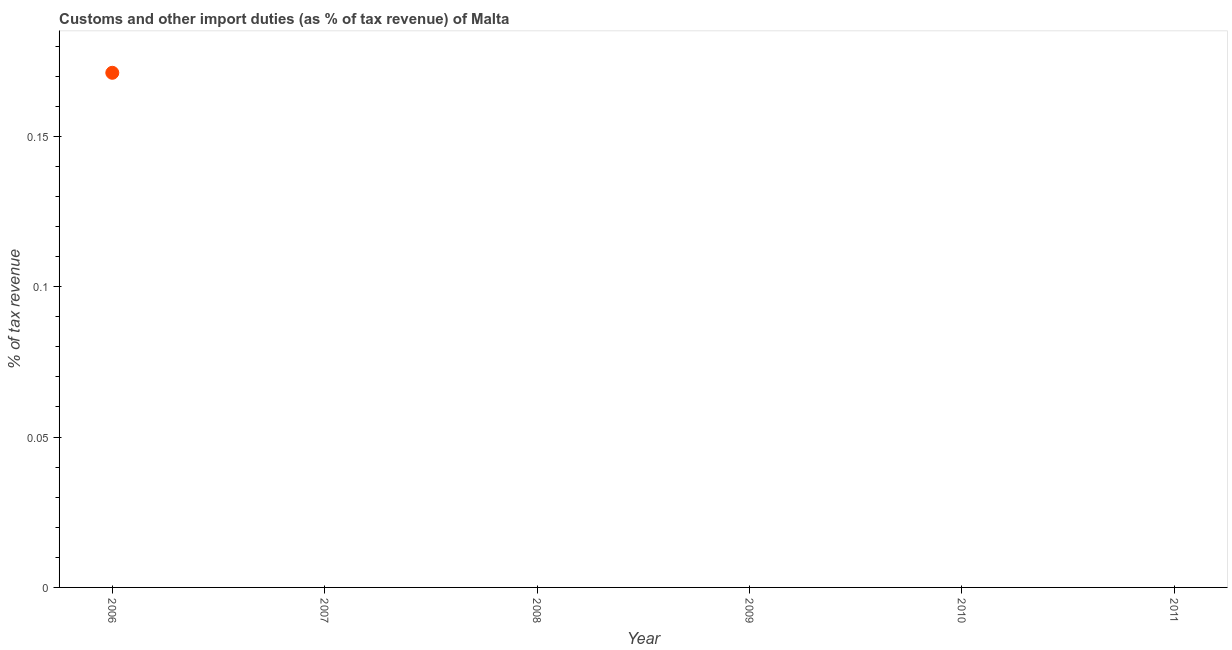What is the customs and other import duties in 2006?
Ensure brevity in your answer.  0.17. Across all years, what is the maximum customs and other import duties?
Make the answer very short. 0.17. In which year was the customs and other import duties maximum?
Ensure brevity in your answer.  2006. What is the sum of the customs and other import duties?
Make the answer very short. 0.17. What is the average customs and other import duties per year?
Keep it short and to the point. 0.03. What is the median customs and other import duties?
Your answer should be compact. 0. In how many years, is the customs and other import duties greater than 0.09 %?
Give a very brief answer. 1. What is the difference between the highest and the lowest customs and other import duties?
Offer a terse response. 0.17. In how many years, is the customs and other import duties greater than the average customs and other import duties taken over all years?
Your answer should be compact. 1. How many years are there in the graph?
Keep it short and to the point. 6. Does the graph contain any zero values?
Offer a terse response. Yes. What is the title of the graph?
Make the answer very short. Customs and other import duties (as % of tax revenue) of Malta. What is the label or title of the Y-axis?
Make the answer very short. % of tax revenue. What is the % of tax revenue in 2006?
Provide a short and direct response. 0.17. What is the % of tax revenue in 2008?
Ensure brevity in your answer.  0. 